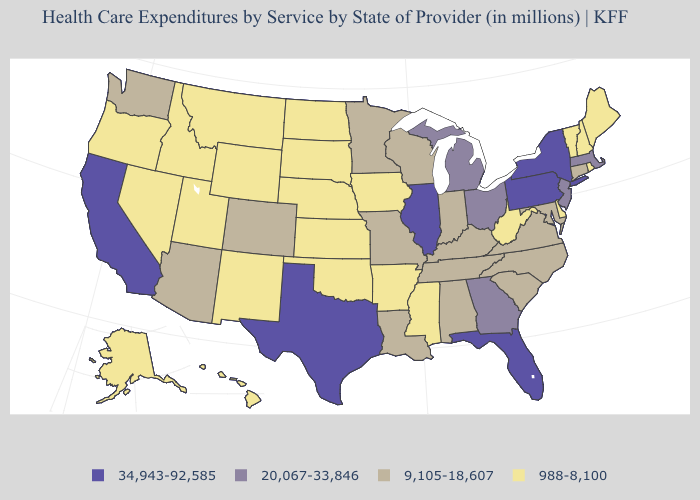Name the states that have a value in the range 988-8,100?
Concise answer only. Alaska, Arkansas, Delaware, Hawaii, Idaho, Iowa, Kansas, Maine, Mississippi, Montana, Nebraska, Nevada, New Hampshire, New Mexico, North Dakota, Oklahoma, Oregon, Rhode Island, South Dakota, Utah, Vermont, West Virginia, Wyoming. Name the states that have a value in the range 20,067-33,846?
Keep it brief. Georgia, Massachusetts, Michigan, New Jersey, Ohio. What is the highest value in the USA?
Give a very brief answer. 34,943-92,585. Which states have the lowest value in the USA?
Be succinct. Alaska, Arkansas, Delaware, Hawaii, Idaho, Iowa, Kansas, Maine, Mississippi, Montana, Nebraska, Nevada, New Hampshire, New Mexico, North Dakota, Oklahoma, Oregon, Rhode Island, South Dakota, Utah, Vermont, West Virginia, Wyoming. Does Virginia have the same value as Oregon?
Write a very short answer. No. What is the highest value in the USA?
Short answer required. 34,943-92,585. Among the states that border Colorado , does Wyoming have the highest value?
Concise answer only. No. Which states have the highest value in the USA?
Be succinct. California, Florida, Illinois, New York, Pennsylvania, Texas. What is the highest value in states that border Idaho?
Short answer required. 9,105-18,607. Name the states that have a value in the range 20,067-33,846?
Answer briefly. Georgia, Massachusetts, Michigan, New Jersey, Ohio. Name the states that have a value in the range 9,105-18,607?
Be succinct. Alabama, Arizona, Colorado, Connecticut, Indiana, Kentucky, Louisiana, Maryland, Minnesota, Missouri, North Carolina, South Carolina, Tennessee, Virginia, Washington, Wisconsin. What is the highest value in the West ?
Keep it brief. 34,943-92,585. What is the value of South Dakota?
Concise answer only. 988-8,100. What is the highest value in the South ?
Concise answer only. 34,943-92,585. Does Illinois have the lowest value in the MidWest?
Short answer required. No. 